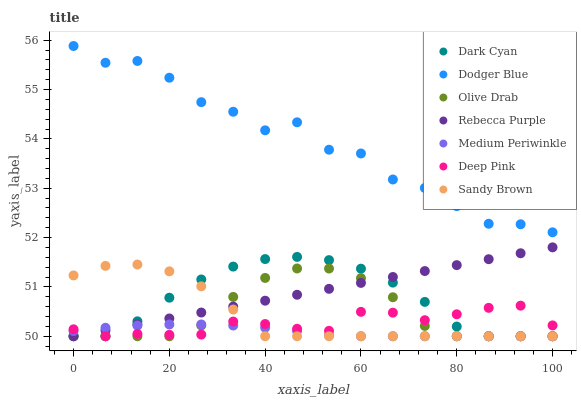Does Medium Periwinkle have the minimum area under the curve?
Answer yes or no. Yes. Does Dodger Blue have the maximum area under the curve?
Answer yes or no. Yes. Does Dodger Blue have the minimum area under the curve?
Answer yes or no. No. Does Medium Periwinkle have the maximum area under the curve?
Answer yes or no. No. Is Rebecca Purple the smoothest?
Answer yes or no. Yes. Is Dodger Blue the roughest?
Answer yes or no. Yes. Is Medium Periwinkle the smoothest?
Answer yes or no. No. Is Medium Periwinkle the roughest?
Answer yes or no. No. Does Deep Pink have the lowest value?
Answer yes or no. Yes. Does Dodger Blue have the lowest value?
Answer yes or no. No. Does Dodger Blue have the highest value?
Answer yes or no. Yes. Does Medium Periwinkle have the highest value?
Answer yes or no. No. Is Deep Pink less than Dodger Blue?
Answer yes or no. Yes. Is Dodger Blue greater than Medium Periwinkle?
Answer yes or no. Yes. Does Dark Cyan intersect Sandy Brown?
Answer yes or no. Yes. Is Dark Cyan less than Sandy Brown?
Answer yes or no. No. Is Dark Cyan greater than Sandy Brown?
Answer yes or no. No. Does Deep Pink intersect Dodger Blue?
Answer yes or no. No. 